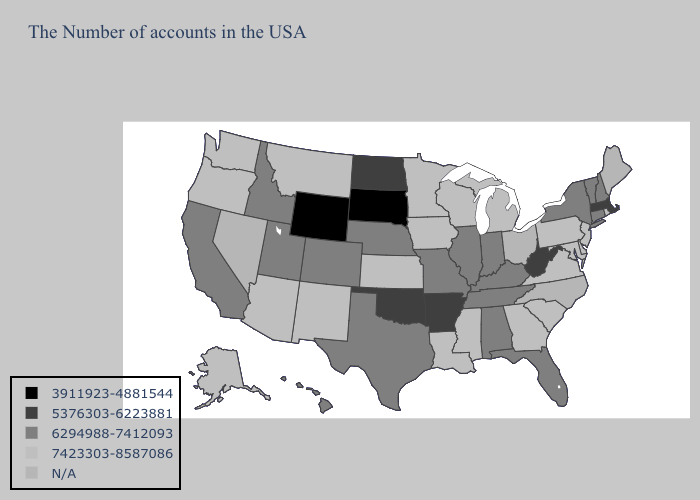What is the value of Alabama?
Concise answer only. 6294988-7412093. Does Alabama have the highest value in the USA?
Write a very short answer. No. Name the states that have a value in the range 5376303-6223881?
Quick response, please. Massachusetts, West Virginia, Arkansas, Oklahoma, North Dakota. What is the value of Indiana?
Write a very short answer. 6294988-7412093. Does Hawaii have the highest value in the West?
Answer briefly. No. Among the states that border Alabama , does Florida have the lowest value?
Concise answer only. Yes. What is the value of Alaska?
Keep it brief. 7423303-8587086. Is the legend a continuous bar?
Short answer required. No. Name the states that have a value in the range 6294988-7412093?
Be succinct. New Hampshire, Vermont, Connecticut, New York, Florida, Kentucky, Indiana, Alabama, Tennessee, Illinois, Missouri, Nebraska, Texas, Colorado, Utah, Idaho, California, Hawaii. Name the states that have a value in the range 6294988-7412093?
Concise answer only. New Hampshire, Vermont, Connecticut, New York, Florida, Kentucky, Indiana, Alabama, Tennessee, Illinois, Missouri, Nebraska, Texas, Colorado, Utah, Idaho, California, Hawaii. What is the lowest value in states that border Montana?
Short answer required. 3911923-4881544. Which states have the lowest value in the MidWest?
Quick response, please. South Dakota. What is the highest value in the Northeast ?
Keep it brief. 7423303-8587086. What is the value of West Virginia?
Answer briefly. 5376303-6223881. 